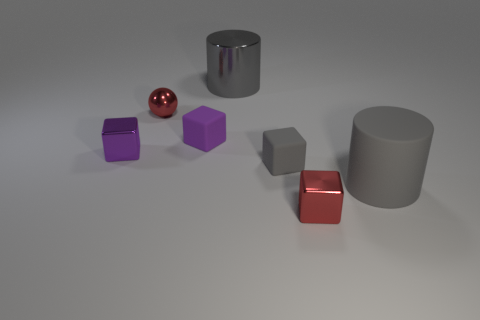Subtract all gray matte cubes. How many cubes are left? 3 Subtract all gray balls. How many purple blocks are left? 2 Subtract all red blocks. How many blocks are left? 3 Subtract all blocks. How many objects are left? 3 Add 3 tiny blue matte cylinders. How many objects exist? 10 Subtract 1 blocks. How many blocks are left? 3 Subtract all green objects. Subtract all metallic spheres. How many objects are left? 6 Add 5 tiny cubes. How many tiny cubes are left? 9 Add 4 small cubes. How many small cubes exist? 8 Subtract 0 green spheres. How many objects are left? 7 